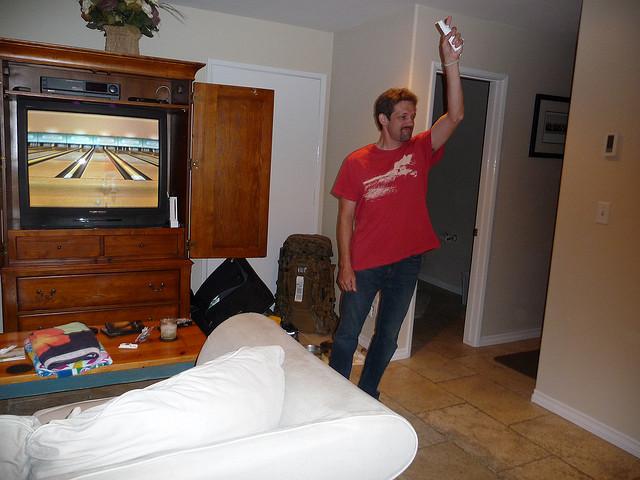Is a bowling game on TV?
Quick response, please. Yes. Is the person playing a video game?
Answer briefly. Yes. How many people are standing?
Answer briefly. 1. Where is the remote control?
Short answer required. In his hand. What is showing on the television?
Quick response, please. Bowling. The man is laying on a bed?
Keep it brief. No. What is the man holding?
Keep it brief. Wii controller. Are they laying down?
Keep it brief. No. What is reflection of?
Answer briefly. Man. 